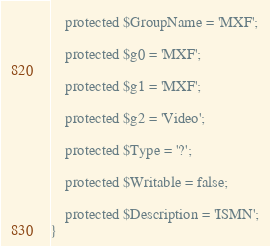Convert code to text. <code><loc_0><loc_0><loc_500><loc_500><_PHP_>
    protected $GroupName = 'MXF';

    protected $g0 = 'MXF';

    protected $g1 = 'MXF';

    protected $g2 = 'Video';

    protected $Type = '?';

    protected $Writable = false;

    protected $Description = 'ISMN';
}
</code> 